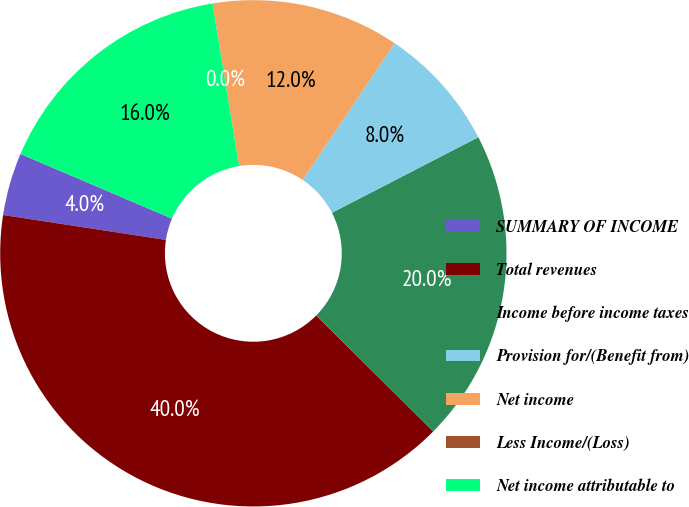<chart> <loc_0><loc_0><loc_500><loc_500><pie_chart><fcel>SUMMARY OF INCOME<fcel>Total revenues<fcel>Income before income taxes<fcel>Provision for/(Benefit from)<fcel>Net income<fcel>Less Income/(Loss)<fcel>Net income attributable to<nl><fcel>4.0%<fcel>40.0%<fcel>20.0%<fcel>8.0%<fcel>12.0%<fcel>0.0%<fcel>16.0%<nl></chart> 